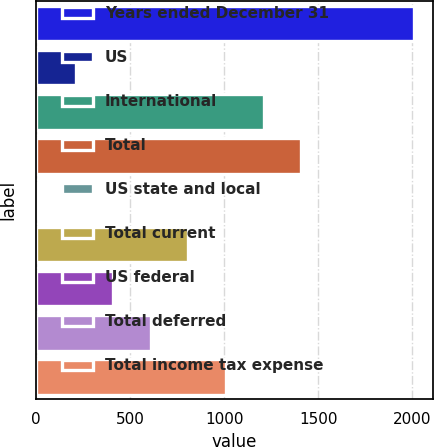Convert chart. <chart><loc_0><loc_0><loc_500><loc_500><bar_chart><fcel>Years ended December 31<fcel>US<fcel>International<fcel>Total<fcel>US state and local<fcel>Total current<fcel>US federal<fcel>Total deferred<fcel>Total income tax expense<nl><fcel>2010<fcel>210<fcel>1210<fcel>1410<fcel>10<fcel>810<fcel>410<fcel>610<fcel>1010<nl></chart> 